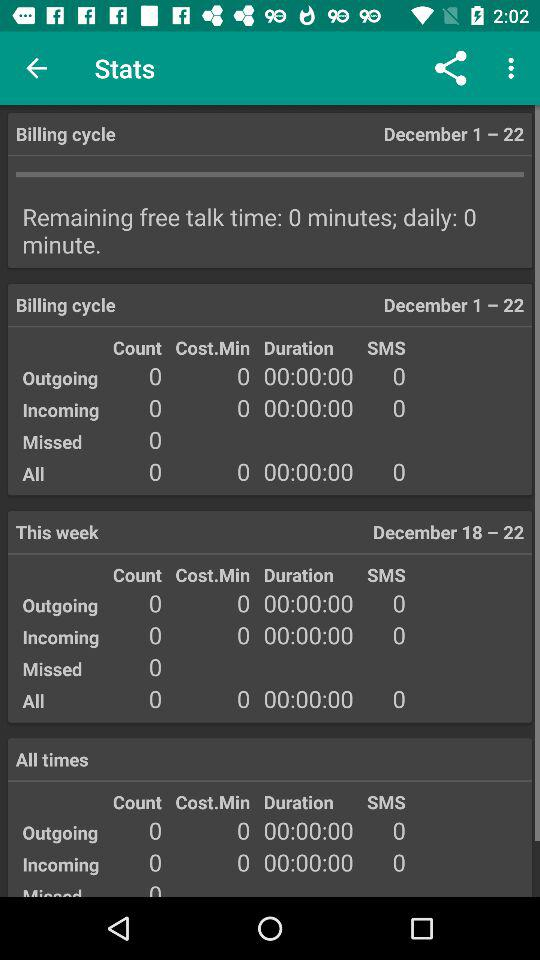What is the remaining free talk time? The remaining free talk time is 0 minutes. 